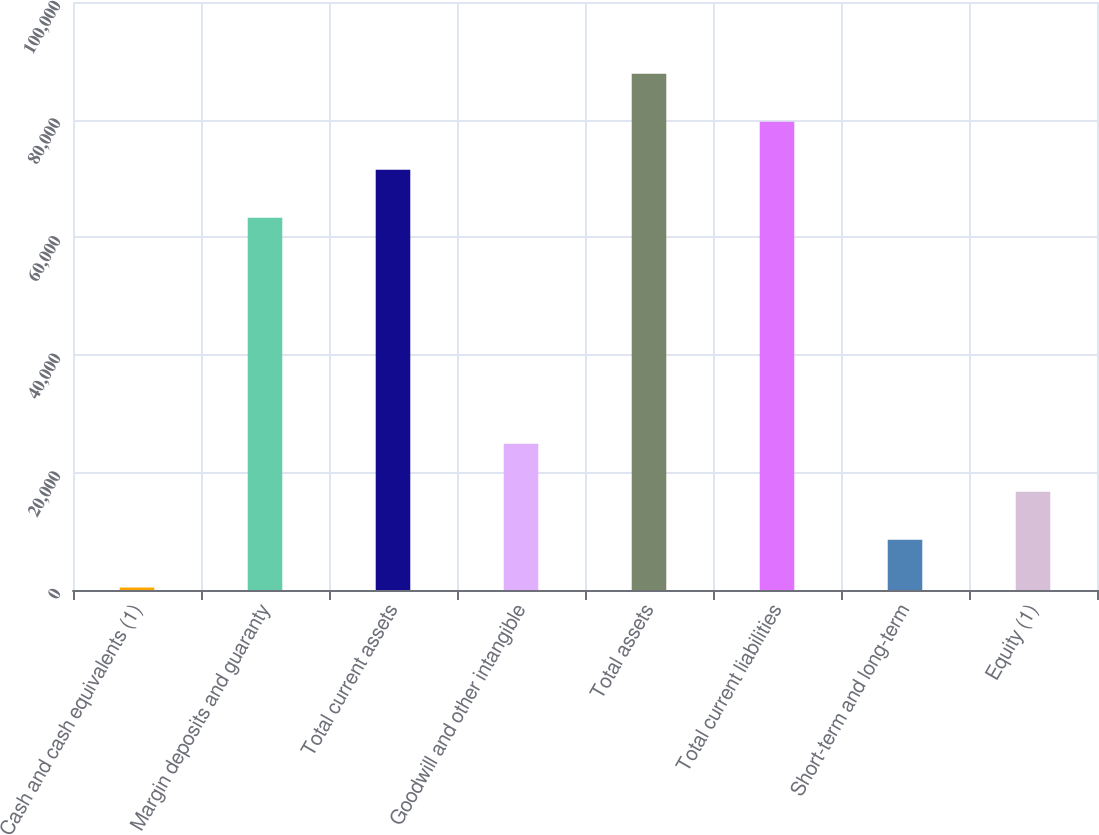Convert chart. <chart><loc_0><loc_0><loc_500><loc_500><bar_chart><fcel>Cash and cash equivalents (1)<fcel>Margin deposits and guaranty<fcel>Total current assets<fcel>Goodwill and other intangible<fcel>Total assets<fcel>Total current liabilities<fcel>Short-term and long-term<fcel>Equity (1)<nl><fcel>407<fcel>63309.6<fcel>71469.2<fcel>24885.8<fcel>87788.4<fcel>79628.8<fcel>8566.6<fcel>16726.2<nl></chart> 